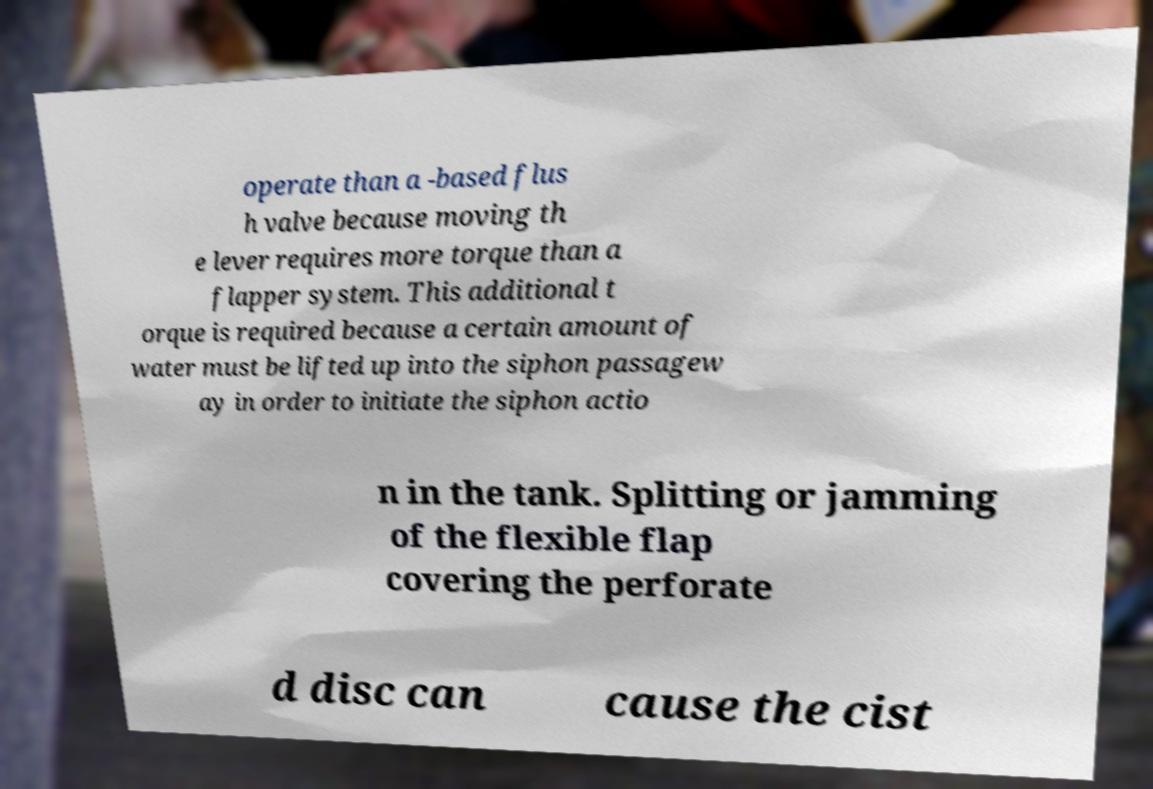Could you extract and type out the text from this image? operate than a -based flus h valve because moving th e lever requires more torque than a flapper system. This additional t orque is required because a certain amount of water must be lifted up into the siphon passagew ay in order to initiate the siphon actio n in the tank. Splitting or jamming of the flexible flap covering the perforate d disc can cause the cist 